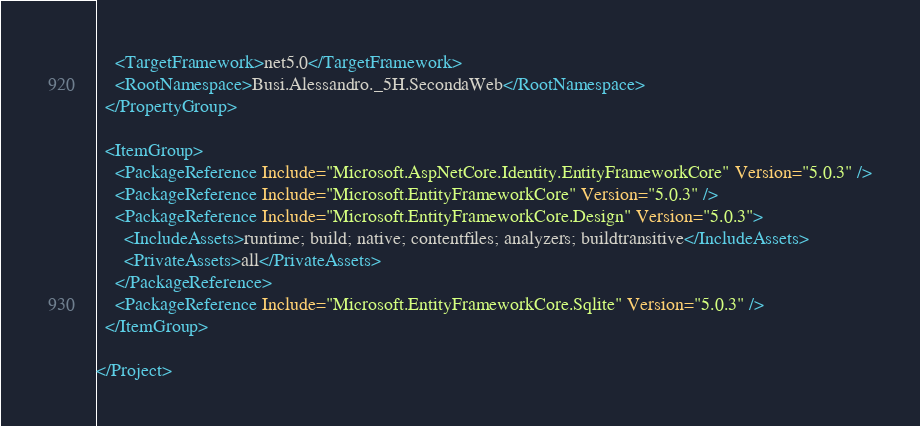<code> <loc_0><loc_0><loc_500><loc_500><_XML_>    <TargetFramework>net5.0</TargetFramework>
    <RootNamespace>Busi.Alessandro._5H.SecondaWeb</RootNamespace>
  </PropertyGroup>

  <ItemGroup>
    <PackageReference Include="Microsoft.AspNetCore.Identity.EntityFrameworkCore" Version="5.0.3" />
    <PackageReference Include="Microsoft.EntityFrameworkCore" Version="5.0.3" />
    <PackageReference Include="Microsoft.EntityFrameworkCore.Design" Version="5.0.3">
      <IncludeAssets>runtime; build; native; contentfiles; analyzers; buildtransitive</IncludeAssets>
      <PrivateAssets>all</PrivateAssets>
    </PackageReference>
    <PackageReference Include="Microsoft.EntityFrameworkCore.Sqlite" Version="5.0.3" />
  </ItemGroup>

</Project>
</code> 